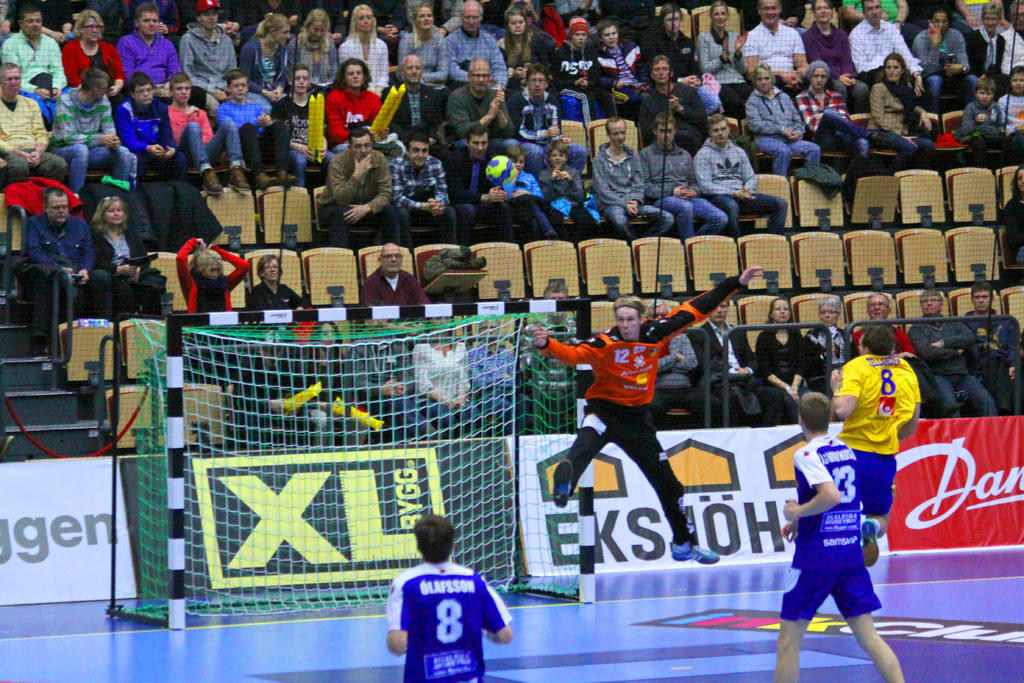Provide a one-sentence caption for the provided image. A handball player in yellow mid-throw, aiming at the goal defended by the goalkeeper in black, with a visible 'XL Bygg' advertisement in the background. 